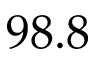Convert formula to latex. <formula><loc_0><loc_0><loc_500><loc_500>9 8 . 8</formula> 